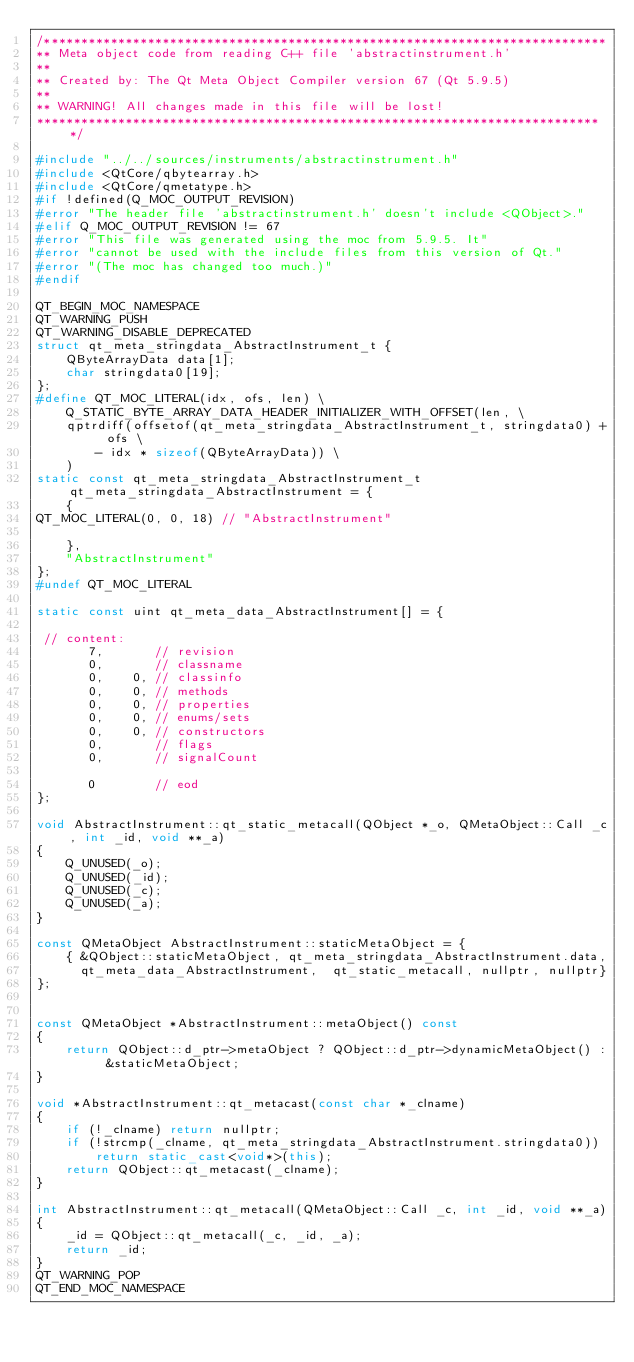<code> <loc_0><loc_0><loc_500><loc_500><_C++_>/****************************************************************************
** Meta object code from reading C++ file 'abstractinstrument.h'
**
** Created by: The Qt Meta Object Compiler version 67 (Qt 5.9.5)
**
** WARNING! All changes made in this file will be lost!
*****************************************************************************/

#include "../../sources/instruments/abstractinstrument.h"
#include <QtCore/qbytearray.h>
#include <QtCore/qmetatype.h>
#if !defined(Q_MOC_OUTPUT_REVISION)
#error "The header file 'abstractinstrument.h' doesn't include <QObject>."
#elif Q_MOC_OUTPUT_REVISION != 67
#error "This file was generated using the moc from 5.9.5. It"
#error "cannot be used with the include files from this version of Qt."
#error "(The moc has changed too much.)"
#endif

QT_BEGIN_MOC_NAMESPACE
QT_WARNING_PUSH
QT_WARNING_DISABLE_DEPRECATED
struct qt_meta_stringdata_AbstractInstrument_t {
    QByteArrayData data[1];
    char stringdata0[19];
};
#define QT_MOC_LITERAL(idx, ofs, len) \
    Q_STATIC_BYTE_ARRAY_DATA_HEADER_INITIALIZER_WITH_OFFSET(len, \
    qptrdiff(offsetof(qt_meta_stringdata_AbstractInstrument_t, stringdata0) + ofs \
        - idx * sizeof(QByteArrayData)) \
    )
static const qt_meta_stringdata_AbstractInstrument_t qt_meta_stringdata_AbstractInstrument = {
    {
QT_MOC_LITERAL(0, 0, 18) // "AbstractInstrument"

    },
    "AbstractInstrument"
};
#undef QT_MOC_LITERAL

static const uint qt_meta_data_AbstractInstrument[] = {

 // content:
       7,       // revision
       0,       // classname
       0,    0, // classinfo
       0,    0, // methods
       0,    0, // properties
       0,    0, // enums/sets
       0,    0, // constructors
       0,       // flags
       0,       // signalCount

       0        // eod
};

void AbstractInstrument::qt_static_metacall(QObject *_o, QMetaObject::Call _c, int _id, void **_a)
{
    Q_UNUSED(_o);
    Q_UNUSED(_id);
    Q_UNUSED(_c);
    Q_UNUSED(_a);
}

const QMetaObject AbstractInstrument::staticMetaObject = {
    { &QObject::staticMetaObject, qt_meta_stringdata_AbstractInstrument.data,
      qt_meta_data_AbstractInstrument,  qt_static_metacall, nullptr, nullptr}
};


const QMetaObject *AbstractInstrument::metaObject() const
{
    return QObject::d_ptr->metaObject ? QObject::d_ptr->dynamicMetaObject() : &staticMetaObject;
}

void *AbstractInstrument::qt_metacast(const char *_clname)
{
    if (!_clname) return nullptr;
    if (!strcmp(_clname, qt_meta_stringdata_AbstractInstrument.stringdata0))
        return static_cast<void*>(this);
    return QObject::qt_metacast(_clname);
}

int AbstractInstrument::qt_metacall(QMetaObject::Call _c, int _id, void **_a)
{
    _id = QObject::qt_metacall(_c, _id, _a);
    return _id;
}
QT_WARNING_POP
QT_END_MOC_NAMESPACE
</code> 